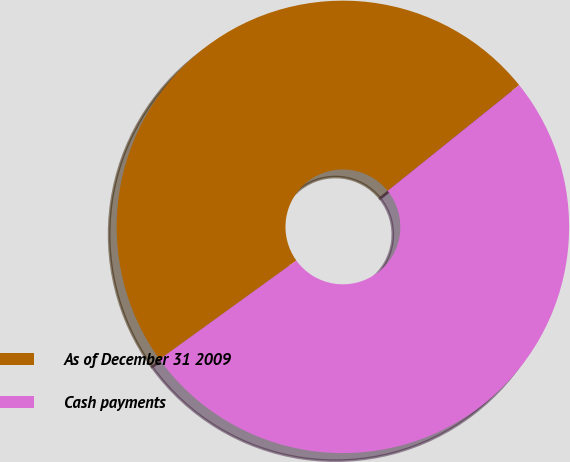<chart> <loc_0><loc_0><loc_500><loc_500><pie_chart><fcel>As of December 31 2009<fcel>Cash payments<nl><fcel>49.18%<fcel>50.82%<nl></chart> 